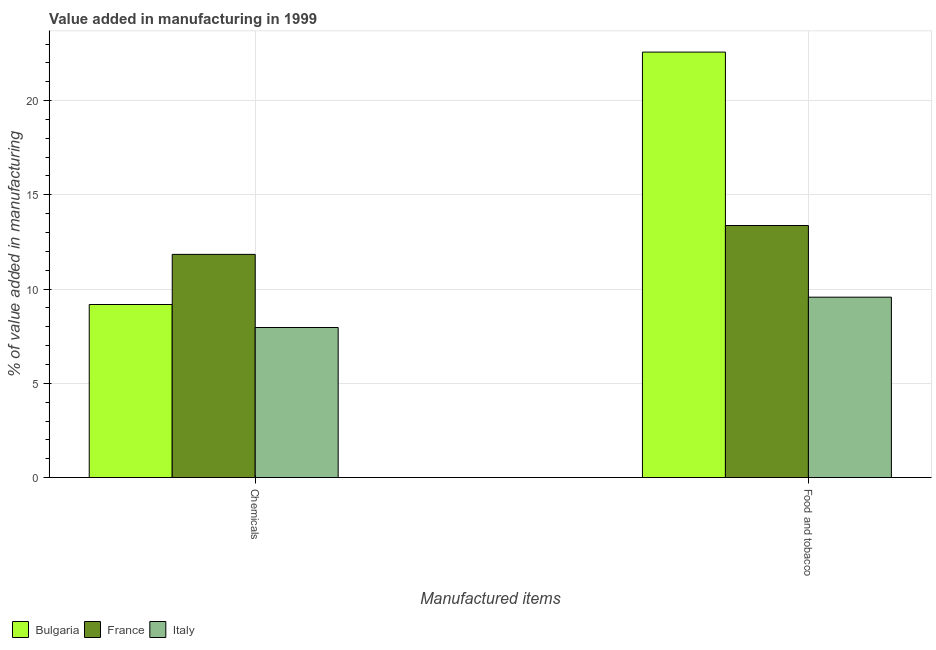How many different coloured bars are there?
Offer a very short reply. 3. Are the number of bars on each tick of the X-axis equal?
Your response must be concise. Yes. What is the label of the 2nd group of bars from the left?
Offer a terse response. Food and tobacco. What is the value added by  manufacturing chemicals in France?
Give a very brief answer. 11.84. Across all countries, what is the maximum value added by  manufacturing chemicals?
Offer a terse response. 11.84. Across all countries, what is the minimum value added by manufacturing food and tobacco?
Provide a succinct answer. 9.57. In which country was the value added by  manufacturing chemicals minimum?
Offer a very short reply. Italy. What is the total value added by manufacturing food and tobacco in the graph?
Your response must be concise. 45.51. What is the difference between the value added by manufacturing food and tobacco in Bulgaria and that in France?
Ensure brevity in your answer.  9.2. What is the difference between the value added by manufacturing food and tobacco in France and the value added by  manufacturing chemicals in Bulgaria?
Provide a short and direct response. 4.19. What is the average value added by  manufacturing chemicals per country?
Provide a succinct answer. 9.66. What is the difference between the value added by  manufacturing chemicals and value added by manufacturing food and tobacco in Bulgaria?
Provide a succinct answer. -13.39. What is the ratio of the value added by  manufacturing chemicals in Italy to that in France?
Give a very brief answer. 0.67. Is the value added by manufacturing food and tobacco in Bulgaria less than that in Italy?
Your response must be concise. No. What does the 1st bar from the left in Food and tobacco represents?
Keep it short and to the point. Bulgaria. How many bars are there?
Provide a short and direct response. 6. Are all the bars in the graph horizontal?
Make the answer very short. No. Are the values on the major ticks of Y-axis written in scientific E-notation?
Offer a terse response. No. Does the graph contain grids?
Make the answer very short. Yes. How many legend labels are there?
Your answer should be very brief. 3. How are the legend labels stacked?
Make the answer very short. Horizontal. What is the title of the graph?
Your response must be concise. Value added in manufacturing in 1999. What is the label or title of the X-axis?
Provide a short and direct response. Manufactured items. What is the label or title of the Y-axis?
Make the answer very short. % of value added in manufacturing. What is the % of value added in manufacturing in Bulgaria in Chemicals?
Provide a succinct answer. 9.18. What is the % of value added in manufacturing of France in Chemicals?
Your answer should be very brief. 11.84. What is the % of value added in manufacturing in Italy in Chemicals?
Make the answer very short. 7.96. What is the % of value added in manufacturing in Bulgaria in Food and tobacco?
Your answer should be compact. 22.57. What is the % of value added in manufacturing of France in Food and tobacco?
Your answer should be very brief. 13.37. What is the % of value added in manufacturing of Italy in Food and tobacco?
Ensure brevity in your answer.  9.57. Across all Manufactured items, what is the maximum % of value added in manufacturing in Bulgaria?
Ensure brevity in your answer.  22.57. Across all Manufactured items, what is the maximum % of value added in manufacturing of France?
Your response must be concise. 13.37. Across all Manufactured items, what is the maximum % of value added in manufacturing in Italy?
Offer a terse response. 9.57. Across all Manufactured items, what is the minimum % of value added in manufacturing in Bulgaria?
Provide a succinct answer. 9.18. Across all Manufactured items, what is the minimum % of value added in manufacturing in France?
Provide a short and direct response. 11.84. Across all Manufactured items, what is the minimum % of value added in manufacturing in Italy?
Provide a succinct answer. 7.96. What is the total % of value added in manufacturing of Bulgaria in the graph?
Make the answer very short. 31.75. What is the total % of value added in manufacturing of France in the graph?
Give a very brief answer. 25.21. What is the total % of value added in manufacturing of Italy in the graph?
Offer a very short reply. 17.53. What is the difference between the % of value added in manufacturing in Bulgaria in Chemicals and that in Food and tobacco?
Make the answer very short. -13.39. What is the difference between the % of value added in manufacturing in France in Chemicals and that in Food and tobacco?
Offer a terse response. -1.53. What is the difference between the % of value added in manufacturing of Italy in Chemicals and that in Food and tobacco?
Offer a very short reply. -1.61. What is the difference between the % of value added in manufacturing in Bulgaria in Chemicals and the % of value added in manufacturing in France in Food and tobacco?
Offer a terse response. -4.19. What is the difference between the % of value added in manufacturing in Bulgaria in Chemicals and the % of value added in manufacturing in Italy in Food and tobacco?
Your response must be concise. -0.39. What is the difference between the % of value added in manufacturing in France in Chemicals and the % of value added in manufacturing in Italy in Food and tobacco?
Provide a succinct answer. 2.27. What is the average % of value added in manufacturing in Bulgaria per Manufactured items?
Provide a succinct answer. 15.88. What is the average % of value added in manufacturing of France per Manufactured items?
Keep it short and to the point. 12.61. What is the average % of value added in manufacturing in Italy per Manufactured items?
Make the answer very short. 8.76. What is the difference between the % of value added in manufacturing in Bulgaria and % of value added in manufacturing in France in Chemicals?
Make the answer very short. -2.66. What is the difference between the % of value added in manufacturing of Bulgaria and % of value added in manufacturing of Italy in Chemicals?
Keep it short and to the point. 1.22. What is the difference between the % of value added in manufacturing of France and % of value added in manufacturing of Italy in Chemicals?
Your response must be concise. 3.88. What is the difference between the % of value added in manufacturing of Bulgaria and % of value added in manufacturing of France in Food and tobacco?
Offer a terse response. 9.2. What is the difference between the % of value added in manufacturing of Bulgaria and % of value added in manufacturing of Italy in Food and tobacco?
Provide a succinct answer. 13. What is the difference between the % of value added in manufacturing in France and % of value added in manufacturing in Italy in Food and tobacco?
Make the answer very short. 3.8. What is the ratio of the % of value added in manufacturing in Bulgaria in Chemicals to that in Food and tobacco?
Your response must be concise. 0.41. What is the ratio of the % of value added in manufacturing of France in Chemicals to that in Food and tobacco?
Provide a succinct answer. 0.89. What is the ratio of the % of value added in manufacturing in Italy in Chemicals to that in Food and tobacco?
Offer a terse response. 0.83. What is the difference between the highest and the second highest % of value added in manufacturing of Bulgaria?
Offer a very short reply. 13.39. What is the difference between the highest and the second highest % of value added in manufacturing in France?
Offer a terse response. 1.53. What is the difference between the highest and the second highest % of value added in manufacturing in Italy?
Provide a short and direct response. 1.61. What is the difference between the highest and the lowest % of value added in manufacturing in Bulgaria?
Provide a short and direct response. 13.39. What is the difference between the highest and the lowest % of value added in manufacturing of France?
Give a very brief answer. 1.53. What is the difference between the highest and the lowest % of value added in manufacturing in Italy?
Ensure brevity in your answer.  1.61. 